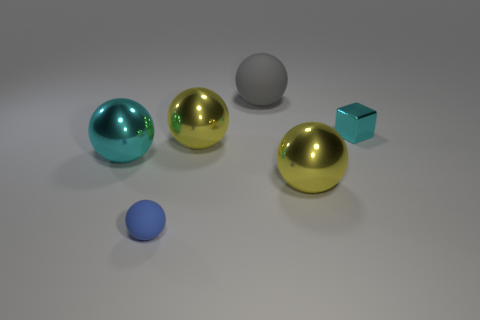Is the material of the blue sphere the same as the cyan object in front of the small metal thing?
Your response must be concise. No. What color is the metallic ball on the right side of the big ball behind the cyan metallic thing that is to the right of the gray sphere?
Offer a very short reply. Yellow. There is a block that is the same size as the blue matte ball; what is it made of?
Ensure brevity in your answer.  Metal. What number of big yellow balls are made of the same material as the blue thing?
Give a very brief answer. 0. There is a metal object that is in front of the large cyan shiny ball; is it the same size as the matte sphere that is behind the big cyan metal ball?
Your answer should be compact. Yes. What color is the matte sphere that is right of the small ball?
Give a very brief answer. Gray. There is a sphere that is the same color as the shiny cube; what is it made of?
Offer a very short reply. Metal. What number of small objects have the same color as the tiny matte sphere?
Offer a very short reply. 0. There is a cube; is it the same size as the rubber object right of the blue matte object?
Offer a very short reply. No. There is a cyan thing that is left of the tiny cyan shiny cube that is right of the yellow thing that is to the left of the big gray ball; what size is it?
Make the answer very short. Large. 